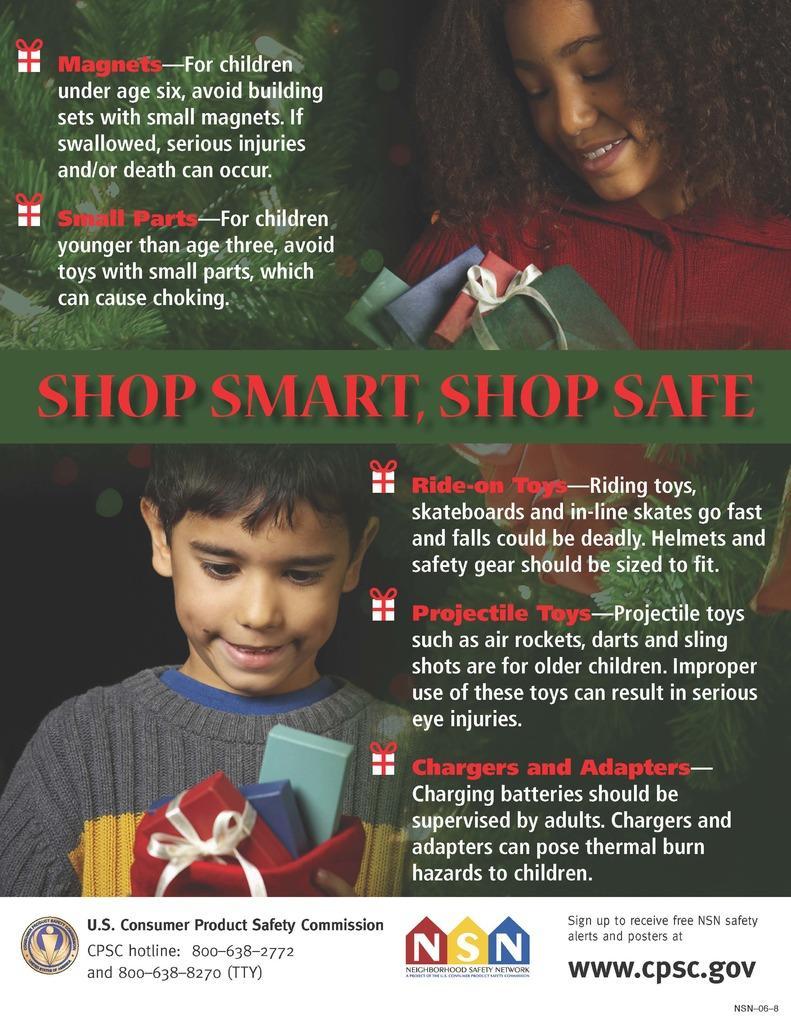In one or two sentences, can you explain what this image depicts? In this image, we can see a poster with some images and text. 